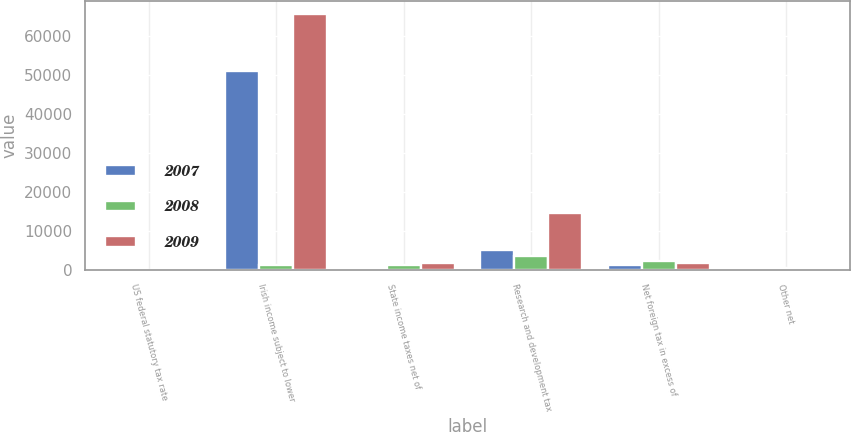Convert chart. <chart><loc_0><loc_0><loc_500><loc_500><stacked_bar_chart><ecel><fcel>US federal statutory tax rate<fcel>Irish income subject to lower<fcel>State income taxes net of<fcel>Research and development tax<fcel>Net foreign tax in excess of<fcel>Other net<nl><fcel>2007<fcel>35<fcel>50972<fcel>406<fcel>5153<fcel>1123<fcel>527<nl><fcel>2008<fcel>35<fcel>1150<fcel>1150<fcel>3401<fcel>2350<fcel>422<nl><fcel>2009<fcel>35<fcel>65673<fcel>1744<fcel>14667<fcel>1729<fcel>547<nl></chart> 